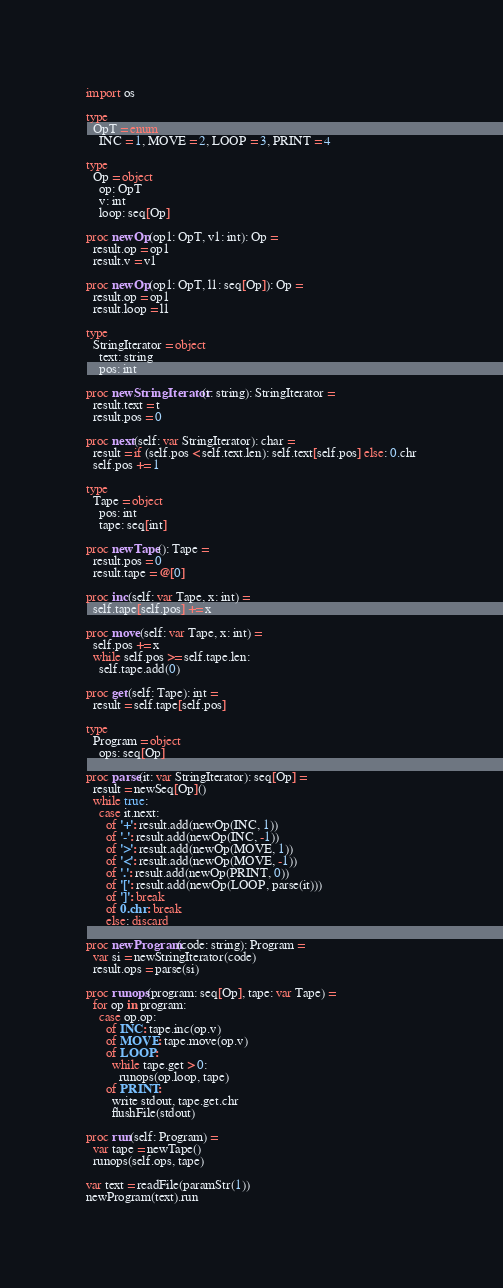<code> <loc_0><loc_0><loc_500><loc_500><_Nim_>import os

type
  OpT = enum
    INC = 1, MOVE = 2, LOOP = 3, PRINT = 4

type 
  Op = object
    op: OpT
    v: int
    loop: seq[Op]

proc newOp(op1: OpT, v1: int): Op =
  result.op = op1
  result.v = v1

proc newOp(op1: OpT, l1: seq[Op]): Op =
  result.op = op1
  result.loop = l1

type 
  StringIterator = object
    text: string
    pos: int

proc newStringIterator(t: string): StringIterator =
  result.text = t
  result.pos = 0

proc next(self: var StringIterator): char =
  result = if (self.pos < self.text.len): self.text[self.pos] else: 0.chr
  self.pos += 1

type
  Tape = object
    pos: int
    tape: seq[int]

proc newTape(): Tape =
  result.pos = 0
  result.tape = @[0]

proc inc(self: var Tape, x: int) =
  self.tape[self.pos] += x

proc move(self: var Tape, x: int) =
  self.pos += x
  while self.pos >= self.tape.len:
    self.tape.add(0)

proc get(self: Tape): int =
  result = self.tape[self.pos]

type
  Program = object
    ops: seq[Op]

proc parse(it: var StringIterator): seq[Op] = 
  result = newSeq[Op]()
  while true:
    case it.next:
      of '+': result.add(newOp(INC, 1))
      of '-': result.add(newOp(INC, -1))
      of '>': result.add(newOp(MOVE, 1))
      of '<': result.add(newOp(MOVE, -1))
      of '.': result.add(newOp(PRINT, 0))
      of '[': result.add(newOp(LOOP, parse(it)))
      of ']': break
      of 0.chr: break
      else: discard

proc newProgram(code: string): Program =
  var si = newStringIterator(code)
  result.ops = parse(si)

proc runops(program: seq[Op], tape: var Tape) =
  for op in program:
    case op.op:
      of INC: tape.inc(op.v)
      of MOVE: tape.move(op.v)
      of LOOP:
        while tape.get > 0:
          runops(op.loop, tape)
      of PRINT: 
        write stdout, tape.get.chr
        flushFile(stdout)

proc run(self: Program) =
  var tape = newTape()
  runops(self.ops, tape)

var text = readFile(paramStr(1))
newProgram(text).run
</code> 